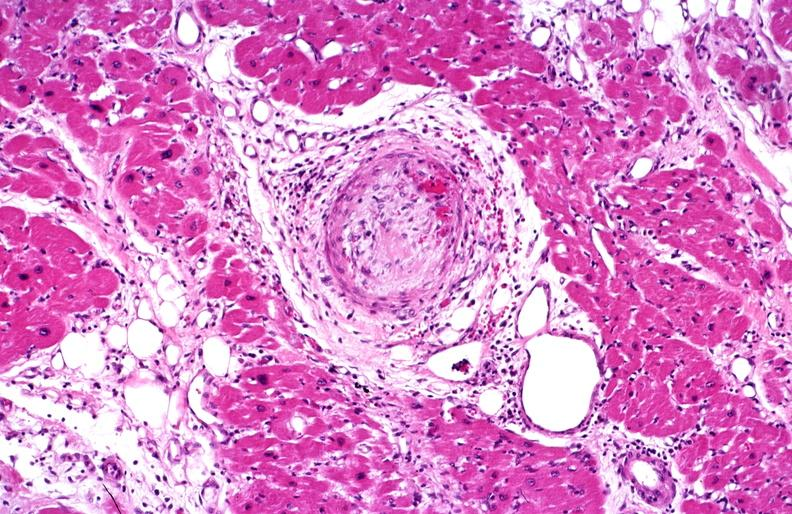where is this from?
Answer the question using a single word or phrase. Heart 